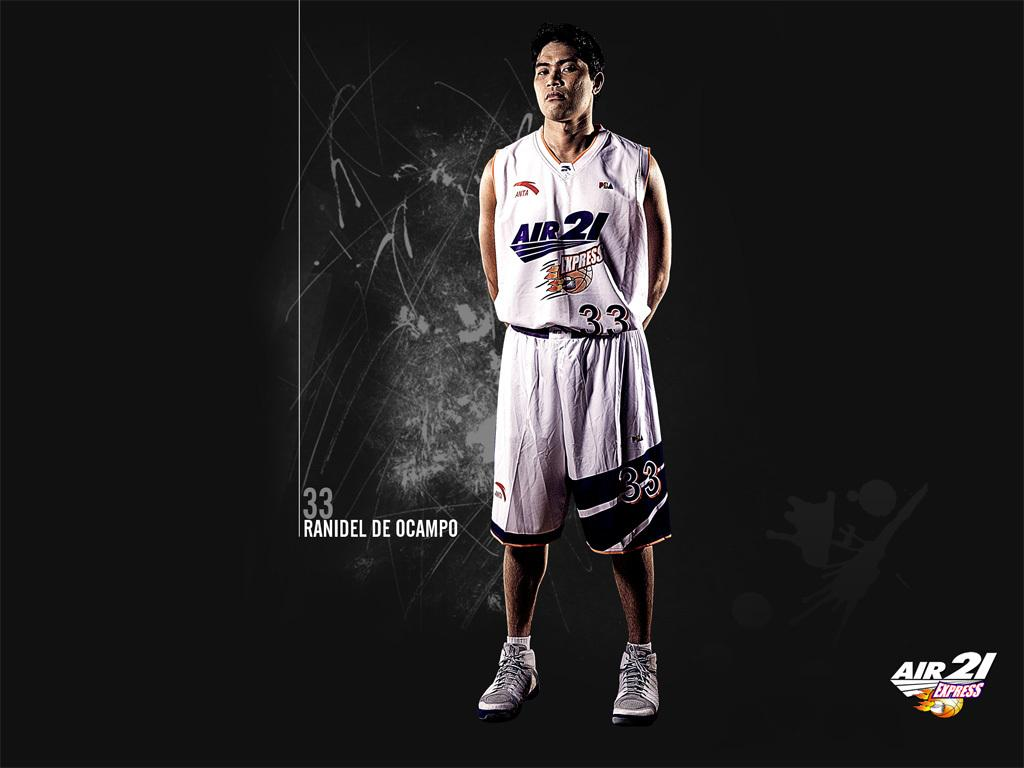<image>
Relay a brief, clear account of the picture shown. A basketball player with a Jersey saying Air 21 